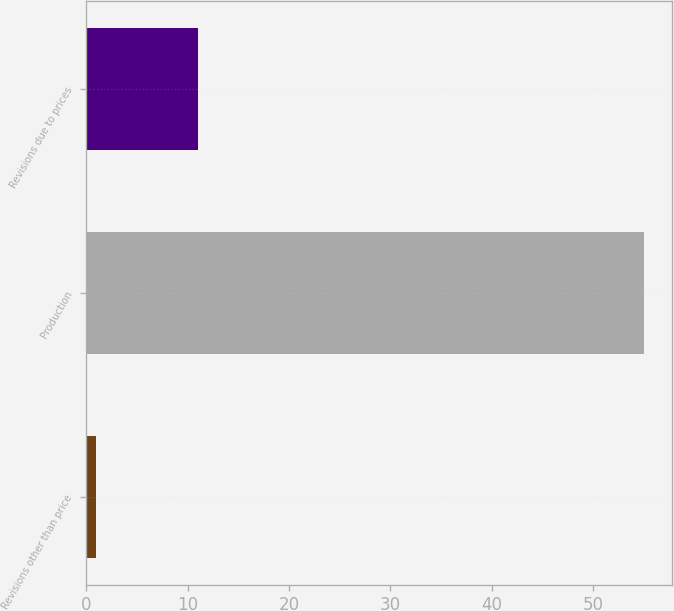Convert chart. <chart><loc_0><loc_0><loc_500><loc_500><bar_chart><fcel>Revisions other than price<fcel>Production<fcel>Revisions due to prices<nl><fcel>1<fcel>55<fcel>11<nl></chart> 